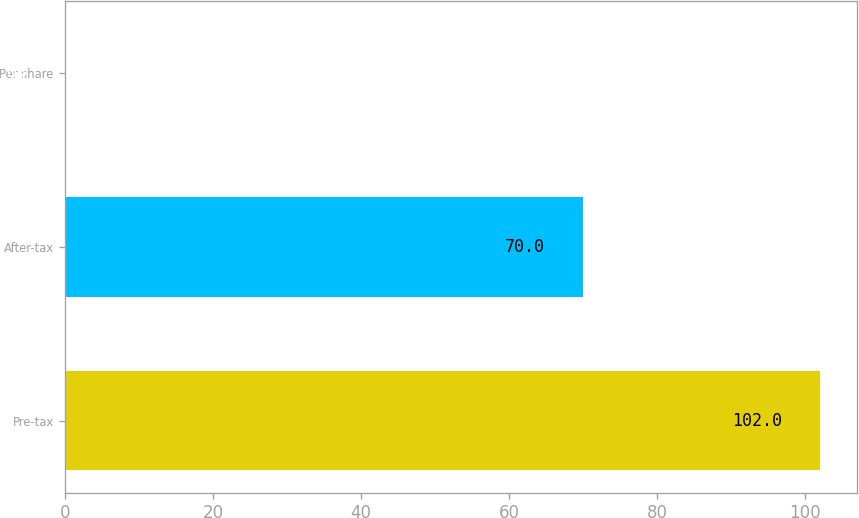Convert chart to OTSL. <chart><loc_0><loc_0><loc_500><loc_500><bar_chart><fcel>Pre-tax<fcel>After-tax<fcel>Per share<nl><fcel>102<fcel>70<fcel>0.04<nl></chart> 